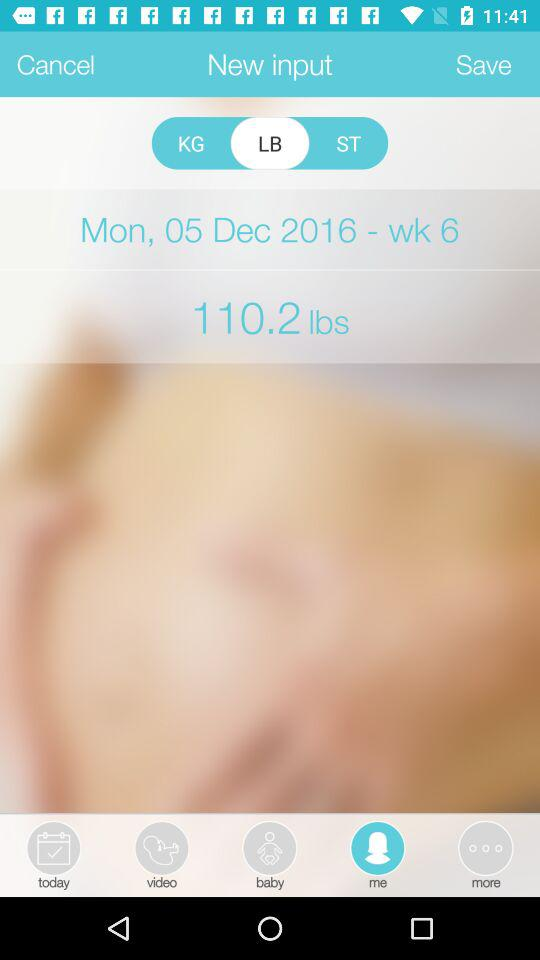What day is it? The day is Monday. 